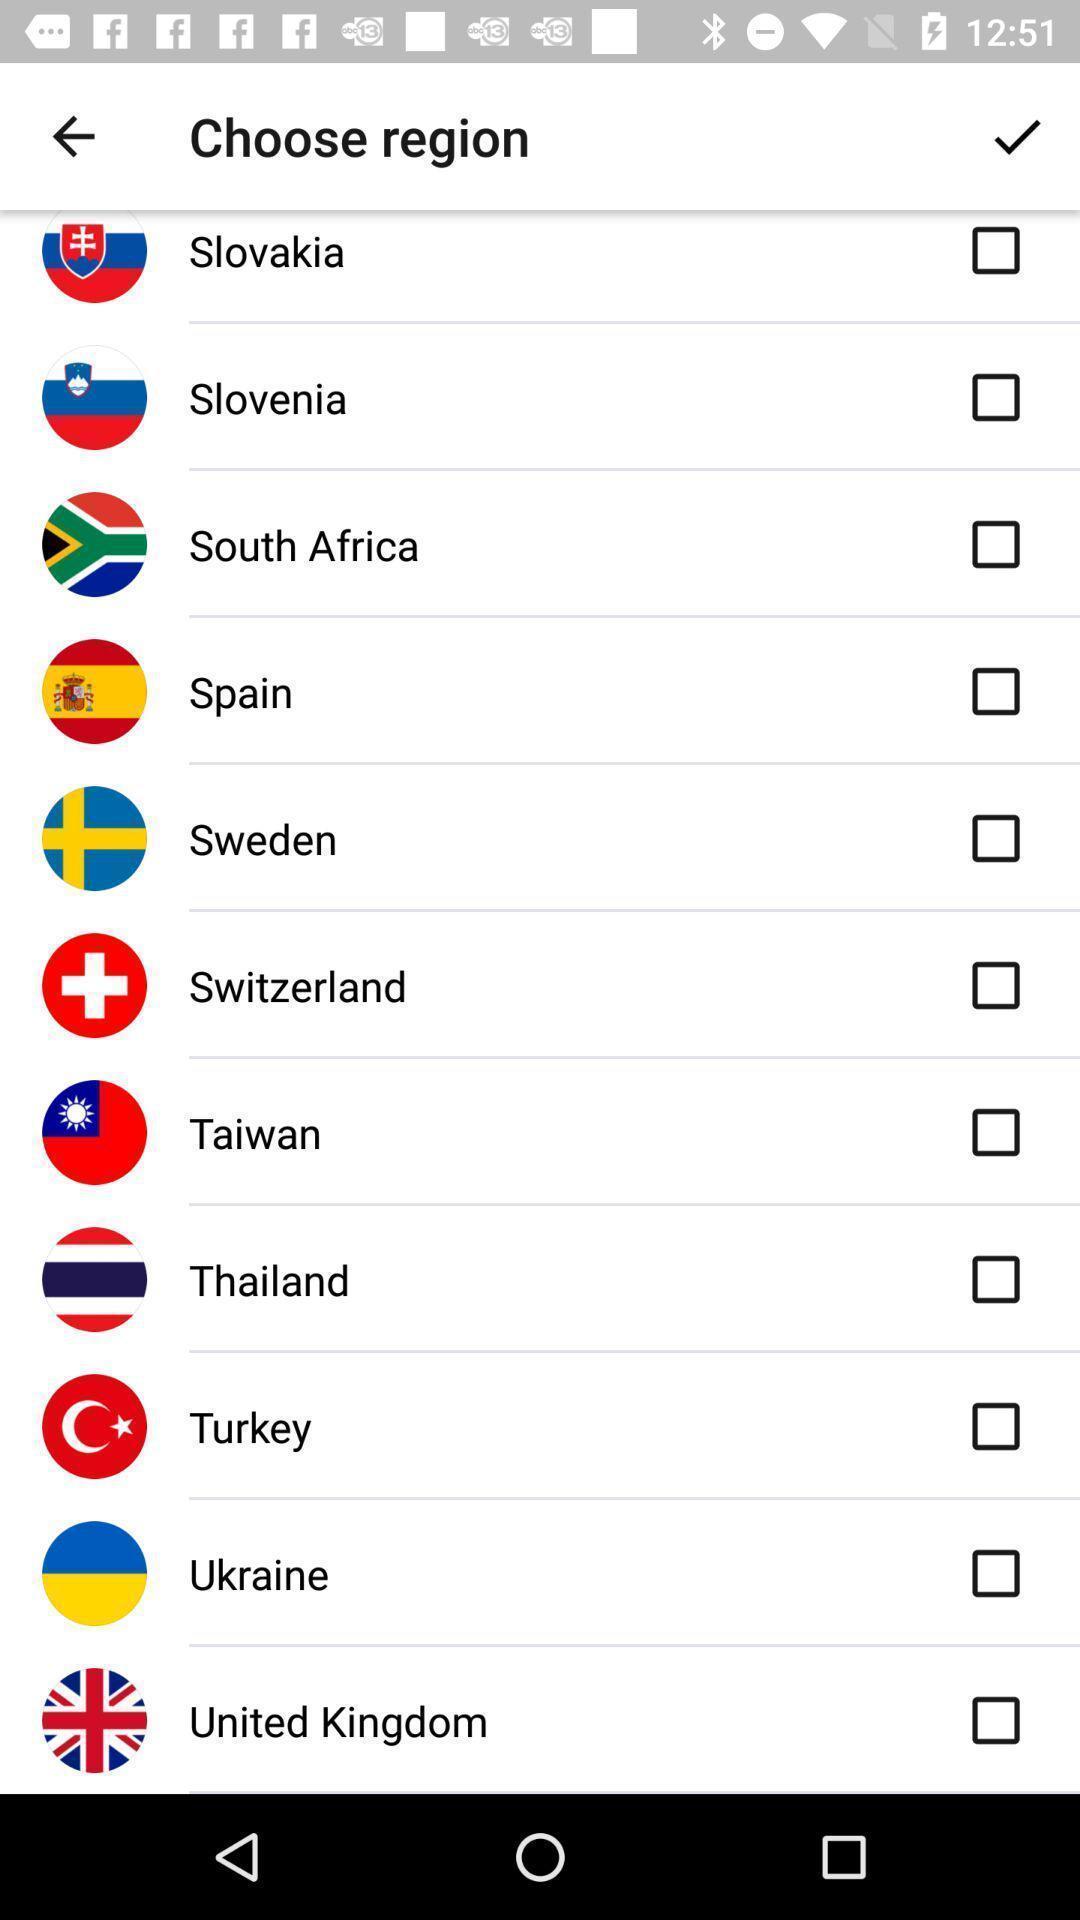Provide a description of this screenshot. Page for choosing a region for an app. 